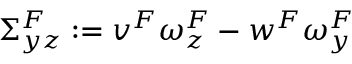Convert formula to latex. <formula><loc_0><loc_0><loc_500><loc_500>\Sigma _ { y z } ^ { F } \colon = v ^ { F } \omega _ { z } ^ { F } - w ^ { F } \omega _ { y } ^ { F }</formula> 